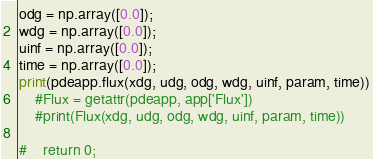<code> <loc_0><loc_0><loc_500><loc_500><_Python_>odg = np.array([0.0]);
wdg = np.array([0.0]);
uinf = np.array([0.0]);
time = np.array([0.0]);
print(pdeapp.flux(xdg, udg, odg, wdg, uinf, param, time))
    #Flux = getattr(pdeapp, app['Flux'])
    #print(Flux(xdg, udg, odg, wdg, uinf, param, time))

#    return 0;
</code> 